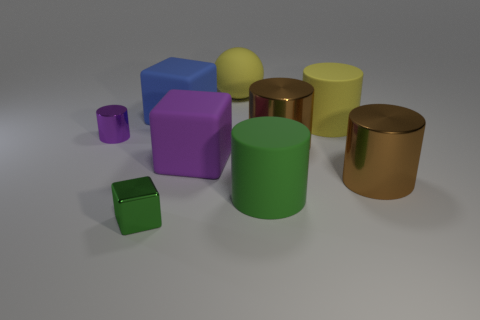Can you describe the lighting environment of where these objects are placed? The objects are placed in a softly-lit environment with diffused shadows indicating an overhead light source, providing a calming and neutral atmosphere suitable for observation or study. 